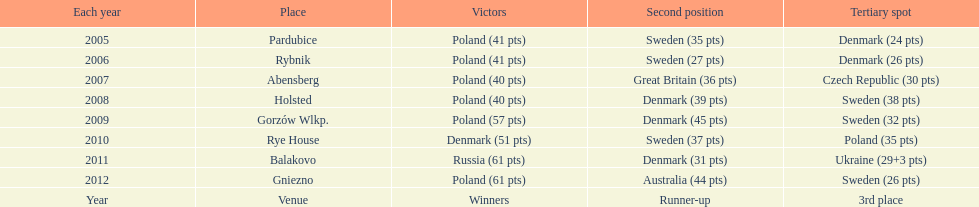From 2005-2012, in the team speedway junior world championship, how many more first place wins than all other teams put together? Poland. 